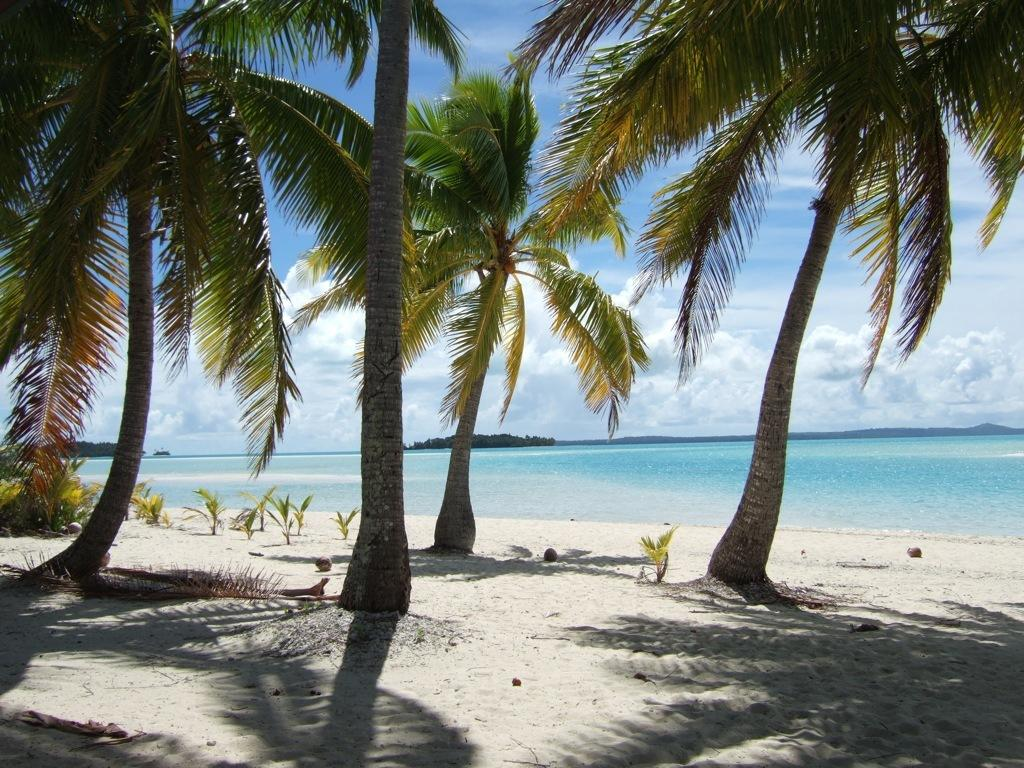What type of environment might the image be set in? The image might be taken on the sea shore, as there is water visible, which is likely an ocean, and sand at the bottom of the image. What type of vegetation can be seen in the image? There are trees and plants visible in the image. What other natural features can be seen in the image? There are mountains visible in the image. What is visible in the sky in the image? The sky is visible in the image. Where is the kitty sleeping in the image? There is no kitty present in the image. What type of attraction can be seen in the image? There is no attraction present in the image; it features natural elements such as the ocean, mountains, and sky. 